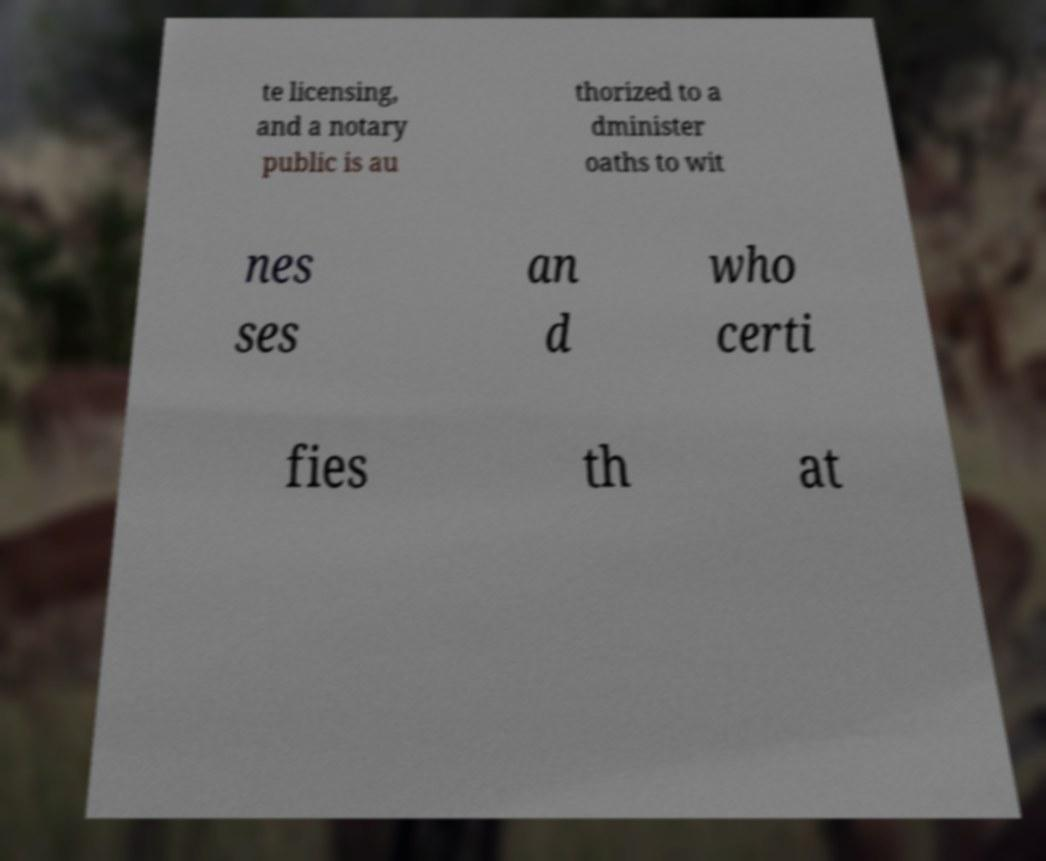Can you accurately transcribe the text from the provided image for me? te licensing, and a notary public is au thorized to a dminister oaths to wit nes ses an d who certi fies th at 